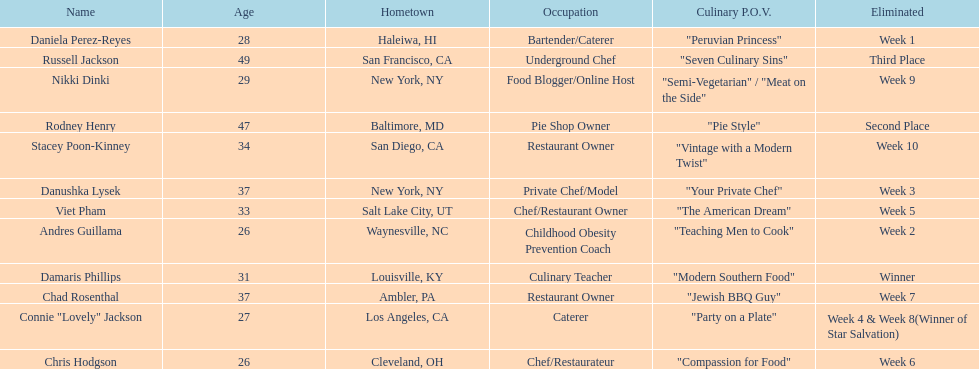How many competitors were under the age of 30? 5. 